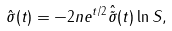Convert formula to latex. <formula><loc_0><loc_0><loc_500><loc_500>\hat { \sigma } ( t ) = - 2 n e ^ { t / 2 } \hat { \tilde { \sigma } } ( t ) \ln S ,</formula> 